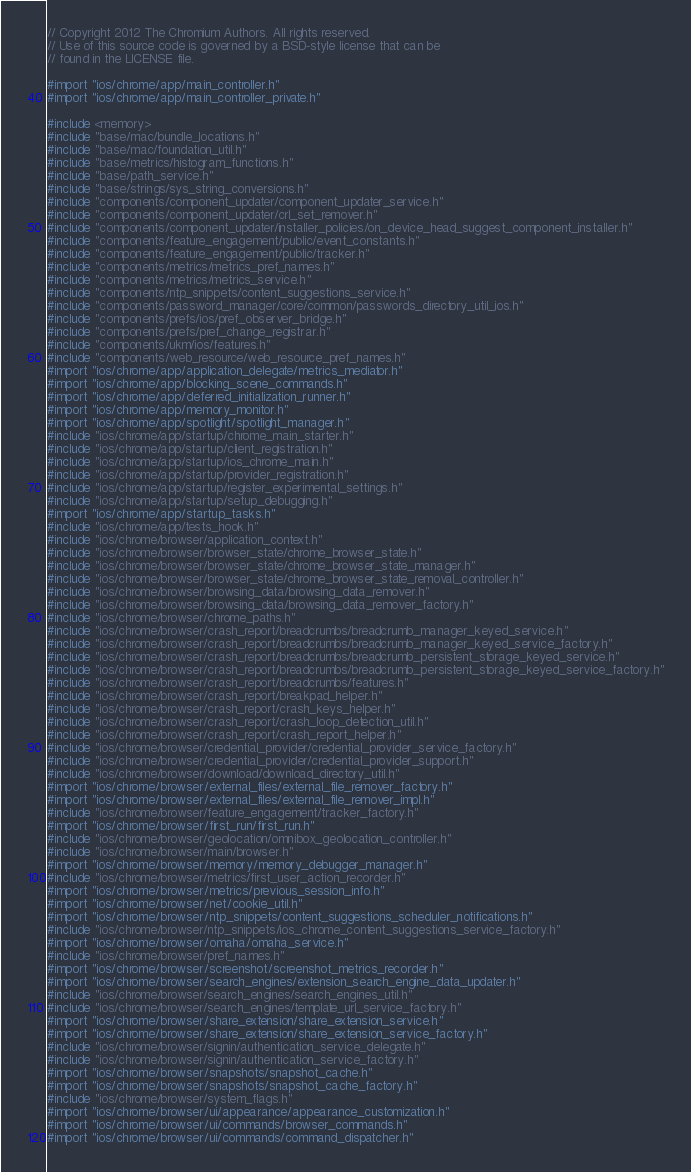Convert code to text. <code><loc_0><loc_0><loc_500><loc_500><_ObjectiveC_>// Copyright 2012 The Chromium Authors. All rights reserved.
// Use of this source code is governed by a BSD-style license that can be
// found in the LICENSE file.

#import "ios/chrome/app/main_controller.h"
#import "ios/chrome/app/main_controller_private.h"

#include <memory>
#include "base/mac/bundle_locations.h"
#include "base/mac/foundation_util.h"
#include "base/metrics/histogram_functions.h"
#include "base/path_service.h"
#include "base/strings/sys_string_conversions.h"
#include "components/component_updater/component_updater_service.h"
#include "components/component_updater/crl_set_remover.h"
#include "components/component_updater/installer_policies/on_device_head_suggest_component_installer.h"
#include "components/feature_engagement/public/event_constants.h"
#include "components/feature_engagement/public/tracker.h"
#include "components/metrics/metrics_pref_names.h"
#include "components/metrics/metrics_service.h"
#include "components/ntp_snippets/content_suggestions_service.h"
#include "components/password_manager/core/common/passwords_directory_util_ios.h"
#include "components/prefs/ios/pref_observer_bridge.h"
#include "components/prefs/pref_change_registrar.h"
#include "components/ukm/ios/features.h"
#include "components/web_resource/web_resource_pref_names.h"
#import "ios/chrome/app/application_delegate/metrics_mediator.h"
#import "ios/chrome/app/blocking_scene_commands.h"
#import "ios/chrome/app/deferred_initialization_runner.h"
#import "ios/chrome/app/memory_monitor.h"
#import "ios/chrome/app/spotlight/spotlight_manager.h"
#include "ios/chrome/app/startup/chrome_main_starter.h"
#include "ios/chrome/app/startup/client_registration.h"
#include "ios/chrome/app/startup/ios_chrome_main.h"
#include "ios/chrome/app/startup/provider_registration.h"
#include "ios/chrome/app/startup/register_experimental_settings.h"
#include "ios/chrome/app/startup/setup_debugging.h"
#import "ios/chrome/app/startup_tasks.h"
#include "ios/chrome/app/tests_hook.h"
#include "ios/chrome/browser/application_context.h"
#include "ios/chrome/browser/browser_state/chrome_browser_state.h"
#include "ios/chrome/browser/browser_state/chrome_browser_state_manager.h"
#include "ios/chrome/browser/browser_state/chrome_browser_state_removal_controller.h"
#include "ios/chrome/browser/browsing_data/browsing_data_remover.h"
#include "ios/chrome/browser/browsing_data/browsing_data_remover_factory.h"
#include "ios/chrome/browser/chrome_paths.h"
#include "ios/chrome/browser/crash_report/breadcrumbs/breadcrumb_manager_keyed_service.h"
#include "ios/chrome/browser/crash_report/breadcrumbs/breadcrumb_manager_keyed_service_factory.h"
#include "ios/chrome/browser/crash_report/breadcrumbs/breadcrumb_persistent_storage_keyed_service.h"
#include "ios/chrome/browser/crash_report/breadcrumbs/breadcrumb_persistent_storage_keyed_service_factory.h"
#include "ios/chrome/browser/crash_report/breadcrumbs/features.h"
#include "ios/chrome/browser/crash_report/breakpad_helper.h"
#include "ios/chrome/browser/crash_report/crash_keys_helper.h"
#include "ios/chrome/browser/crash_report/crash_loop_detection_util.h"
#include "ios/chrome/browser/crash_report/crash_report_helper.h"
#include "ios/chrome/browser/credential_provider/credential_provider_service_factory.h"
#include "ios/chrome/browser/credential_provider/credential_provider_support.h"
#include "ios/chrome/browser/download/download_directory_util.h"
#import "ios/chrome/browser/external_files/external_file_remover_factory.h"
#import "ios/chrome/browser/external_files/external_file_remover_impl.h"
#include "ios/chrome/browser/feature_engagement/tracker_factory.h"
#import "ios/chrome/browser/first_run/first_run.h"
#include "ios/chrome/browser/geolocation/omnibox_geolocation_controller.h"
#include "ios/chrome/browser/main/browser.h"
#import "ios/chrome/browser/memory/memory_debugger_manager.h"
#include "ios/chrome/browser/metrics/first_user_action_recorder.h"
#import "ios/chrome/browser/metrics/previous_session_info.h"
#import "ios/chrome/browser/net/cookie_util.h"
#import "ios/chrome/browser/ntp_snippets/content_suggestions_scheduler_notifications.h"
#include "ios/chrome/browser/ntp_snippets/ios_chrome_content_suggestions_service_factory.h"
#import "ios/chrome/browser/omaha/omaha_service.h"
#include "ios/chrome/browser/pref_names.h"
#import "ios/chrome/browser/screenshot/screenshot_metrics_recorder.h"
#import "ios/chrome/browser/search_engines/extension_search_engine_data_updater.h"
#include "ios/chrome/browser/search_engines/search_engines_util.h"
#include "ios/chrome/browser/search_engines/template_url_service_factory.h"
#import "ios/chrome/browser/share_extension/share_extension_service.h"
#import "ios/chrome/browser/share_extension/share_extension_service_factory.h"
#include "ios/chrome/browser/signin/authentication_service_delegate.h"
#include "ios/chrome/browser/signin/authentication_service_factory.h"
#import "ios/chrome/browser/snapshots/snapshot_cache.h"
#import "ios/chrome/browser/snapshots/snapshot_cache_factory.h"
#include "ios/chrome/browser/system_flags.h"
#import "ios/chrome/browser/ui/appearance/appearance_customization.h"
#import "ios/chrome/browser/ui/commands/browser_commands.h"
#import "ios/chrome/browser/ui/commands/command_dispatcher.h"</code> 